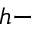Convert formula to latex. <formula><loc_0><loc_0><loc_500><loc_500>h -</formula> 